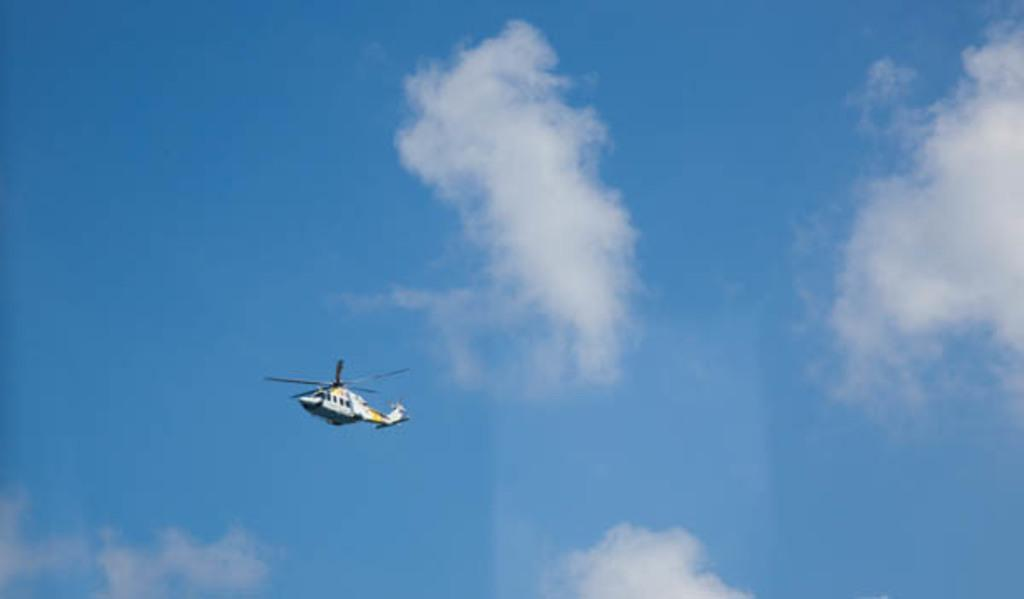What is the main subject of the image? The main subject of the image is a helicopter. What is the helicopter doing in the image? The helicopter is flying in the air. What can be seen in the background of the image? The sky is visible in the background of the image. What is the color of the sky in the image? The sky is blue in the image. Are there any additional features in the sky? Yes, there are clouds in the sky. What type of throat lozenges can be seen in the image? There are no throat lozenges present in the image; it features a helicopter flying in the sky. 